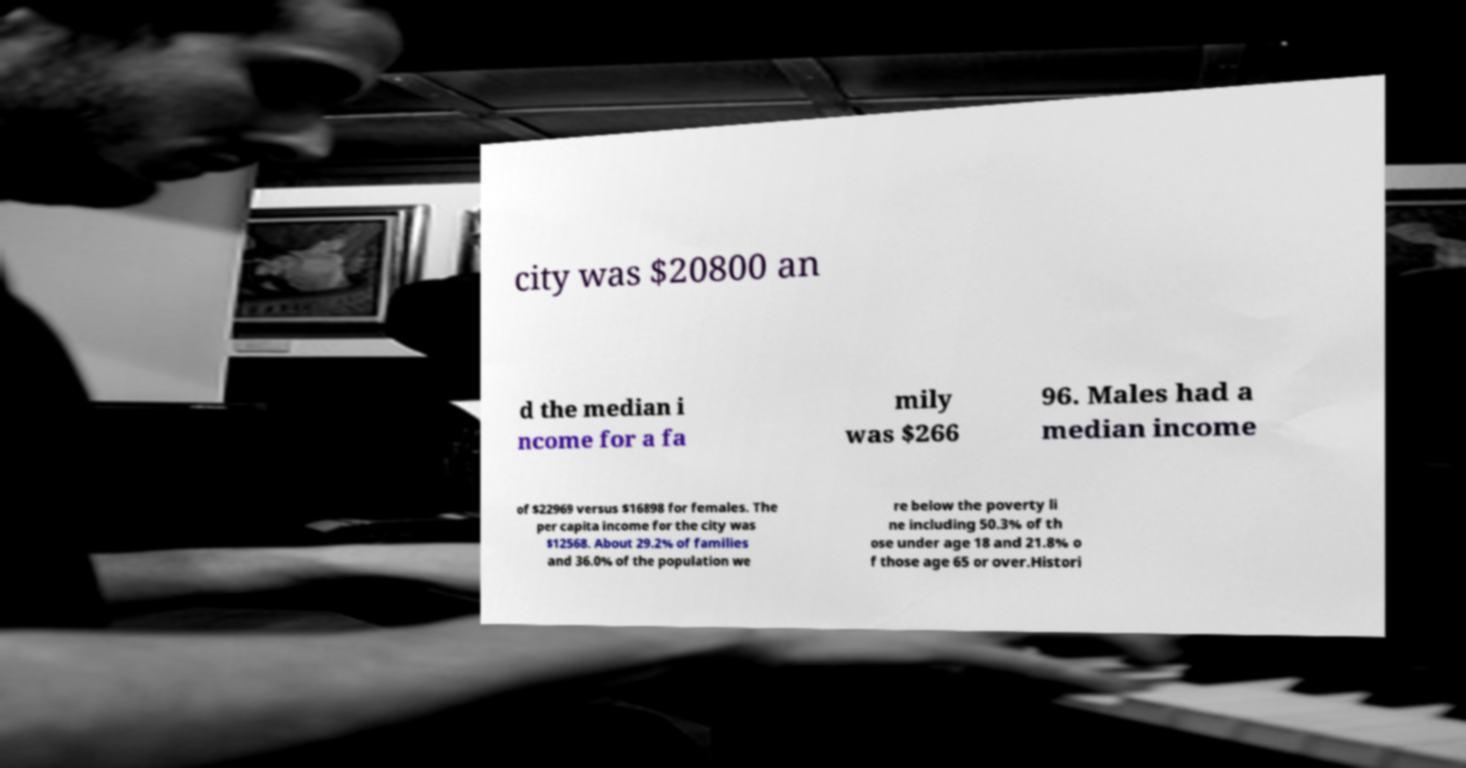For documentation purposes, I need the text within this image transcribed. Could you provide that? city was $20800 an d the median i ncome for a fa mily was $266 96. Males had a median income of $22969 versus $16898 for females. The per capita income for the city was $12568. About 29.2% of families and 36.0% of the population we re below the poverty li ne including 50.3% of th ose under age 18 and 21.8% o f those age 65 or over.Histori 